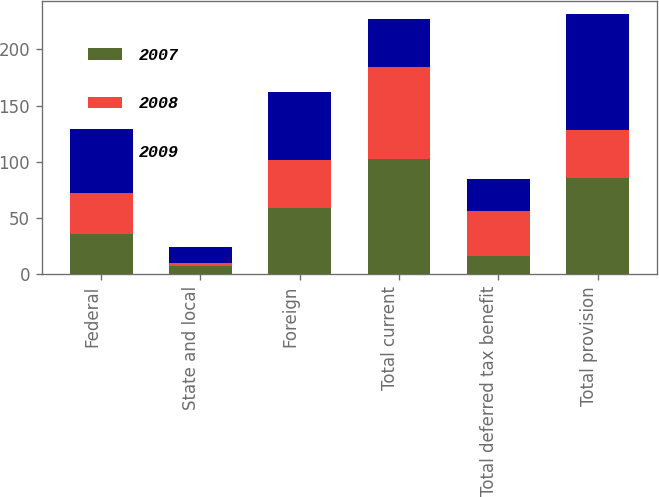<chart> <loc_0><loc_0><loc_500><loc_500><stacked_bar_chart><ecel><fcel>Federal<fcel>State and local<fcel>Foreign<fcel>Total current<fcel>Total deferred tax benefit<fcel>Total provision<nl><fcel>2007<fcel>35.8<fcel>7.1<fcel>59.3<fcel>102.2<fcel>16.6<fcel>85.6<nl><fcel>2008<fcel>36.7<fcel>2.6<fcel>42.6<fcel>81.9<fcel>39.5<fcel>42.4<nl><fcel>2009<fcel>56.8<fcel>14.2<fcel>60.5<fcel>42.4<fcel>28.5<fcel>103<nl></chart> 